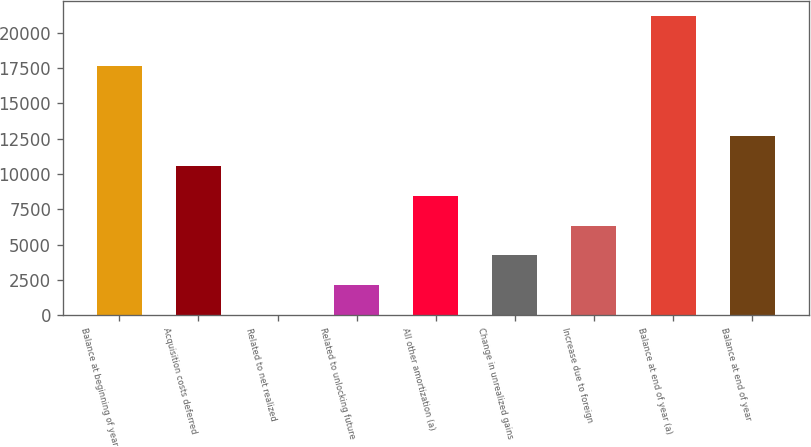Convert chart to OTSL. <chart><loc_0><loc_0><loc_500><loc_500><bar_chart><fcel>Balance at beginning of year<fcel>Acquisition costs deferred<fcel>Related to net realized<fcel>Related to unlocking future<fcel>All other amortization (a)<fcel>Change in unrealized gains<fcel>Increase due to foreign<fcel>Balance at end of year (a)<fcel>Balance at end of year<nl><fcel>17638<fcel>10579<fcel>5<fcel>2119.8<fcel>8464.2<fcel>4234.6<fcel>6349.4<fcel>21153<fcel>12693.8<nl></chart> 